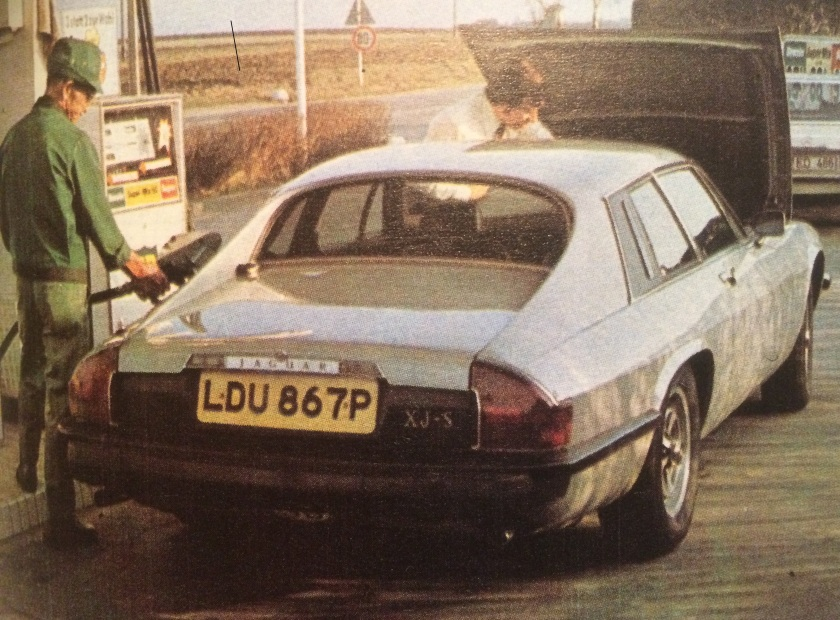What are some of the possible reasons for the car's boot being open? There could be several reasons for the car's boot being open. It's possible that the driver is storing or retrieving luggage or other items. Alternatively, they might be checking or adjusting something in the trunk, such as the spare tire, or ensuring that the boot is properly closed. Given the era, it might also be that someone is showing off the storage capacity of the Jaguar XJ-S, or even preparing the car for a longer journey. Considering the era, could there be a scenario involving roadside assistance happening here? Indeed, it's plausible that roadside assistance could be involved. During the 1970s, it was not uncommon for cars to experience mechanical issues, and the driver's open boot might indicate they were trying to fix a problem or retrieve tools or a spare tire. The attendant could be offering help, either by providing fuel or by assisting with the mechanical issue. Alternatively, they might be refueling the car while the driver checks on or addresses a separate concern. 